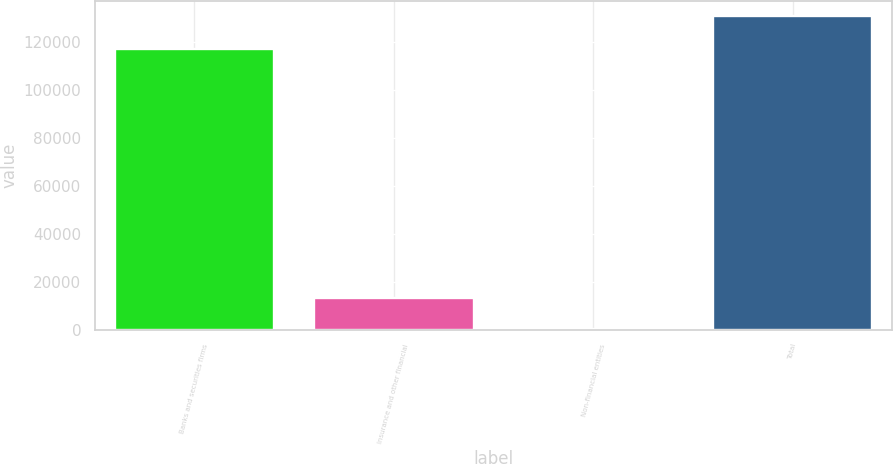Convert chart. <chart><loc_0><loc_0><loc_500><loc_500><bar_chart><fcel>Banks and securities firms<fcel>Insurance and other financial<fcel>Non-financial entities<fcel>Total<nl><fcel>117125<fcel>13334<fcel>262<fcel>130726<nl></chart> 